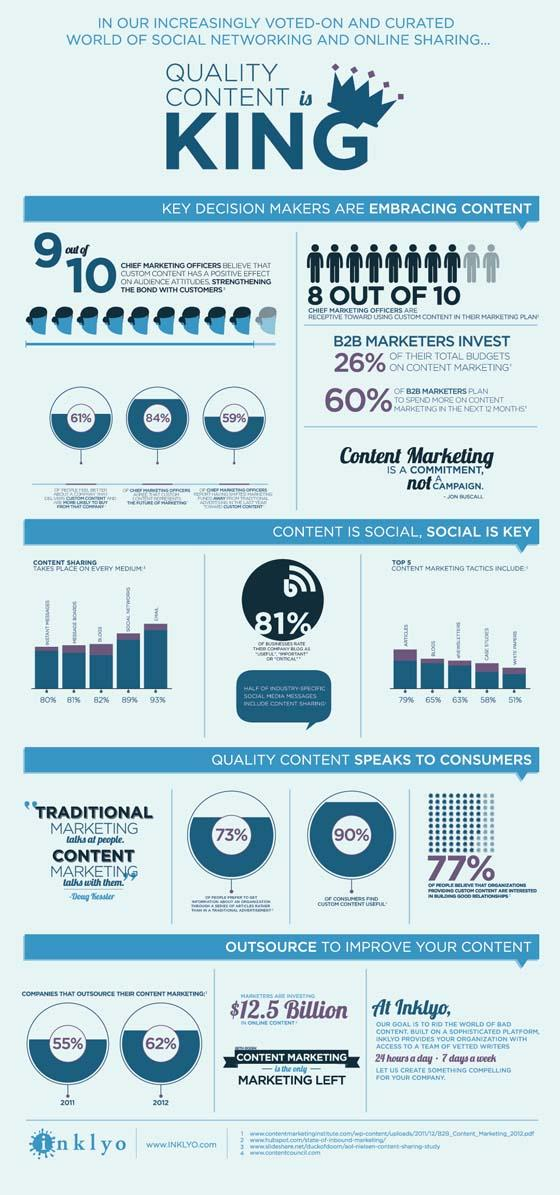Give some essential details in this illustration. In 2012, 62% of companies outsourced their content marketing. Forty percent of B2B marketers do not plan to spend more on content marketing in the next 12 months. It was reported in 2011 that 55% of companies outsourced their content marketing. 